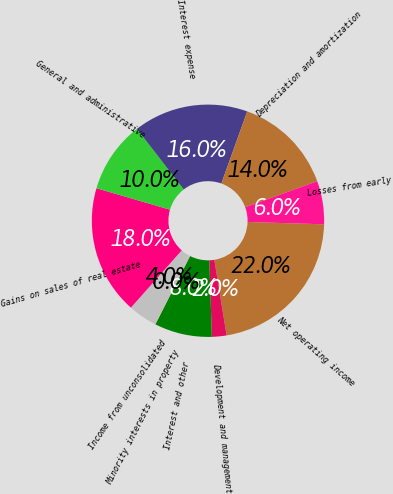<chart> <loc_0><loc_0><loc_500><loc_500><pie_chart><fcel>Net operating income<fcel>Development and management<fcel>Interest and other<fcel>Minority interests in property<fcel>Income from unconsolidated<fcel>Gains on sales of real estate<fcel>General and administrative<fcel>Interest expense<fcel>Depreciation and amortization<fcel>Losses from early<nl><fcel>21.95%<fcel>2.03%<fcel>8.01%<fcel>0.04%<fcel>4.03%<fcel>17.97%<fcel>10.0%<fcel>15.97%<fcel>13.98%<fcel>6.02%<nl></chart> 